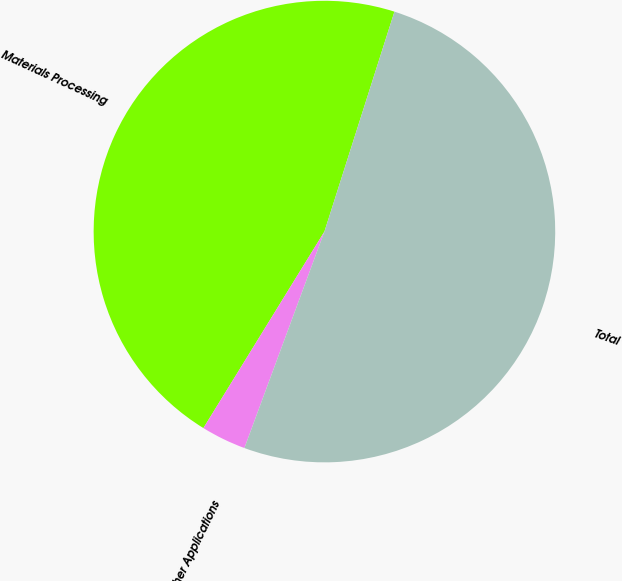<chart> <loc_0><loc_0><loc_500><loc_500><pie_chart><fcel>Materials Processing<fcel>Other Applications<fcel>Total<nl><fcel>46.12%<fcel>3.15%<fcel>50.73%<nl></chart> 